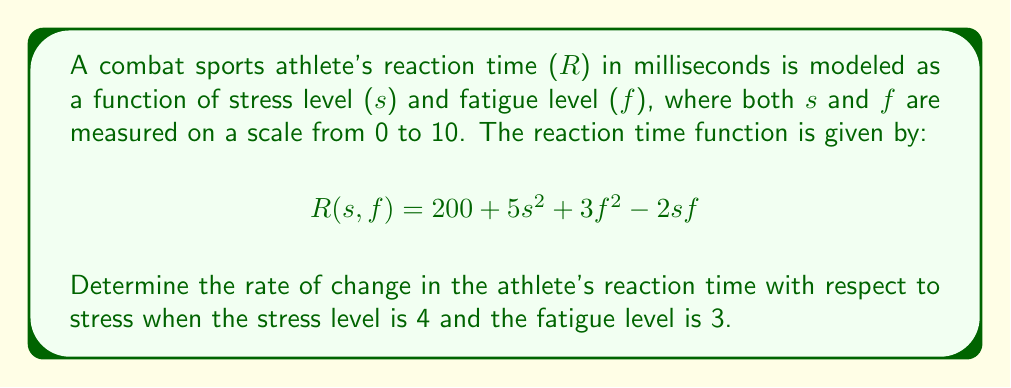Provide a solution to this math problem. To solve this problem, we need to use partial differentiation. We want to find the rate of change of reaction time with respect to stress, which means we need to calculate the partial derivative of R with respect to s.

1. First, let's find the partial derivative $\frac{\partial R}{\partial s}$:

   $$\frac{\partial R}{\partial s} = 10s - 2f$$

2. Now that we have the partial derivative, we can substitute the given values:
   s = 4 (stress level)
   f = 3 (fatigue level)

3. Plugging these values into our partial derivative:

   $$\frac{\partial R}{\partial s}\bigg|_{(s=4,f=3)} = 10(4) - 2(3)$$

4. Simplify:
   $$\frac{\partial R}{\partial s}\bigg|_{(s=4,f=3)} = 40 - 6 = 34$$

This result means that when the stress level is 4 and the fatigue level is 3, the reaction time is increasing at a rate of 34 milliseconds per unit increase in stress.
Answer: The rate of change in the athlete's reaction time with respect to stress, when stress level is 4 and fatigue level is 3, is 34 milliseconds per unit of stress. 